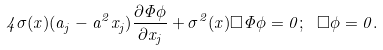Convert formula to latex. <formula><loc_0><loc_0><loc_500><loc_500>4 \sigma ( x ) ( a _ { j } - a ^ { 2 } x _ { j } ) \frac { \partial \Phi \phi } { \partial x _ { j } } + \sigma ^ { 2 } ( x ) \Box \Phi \phi = 0 ; \ \Box \phi = 0 .</formula> 